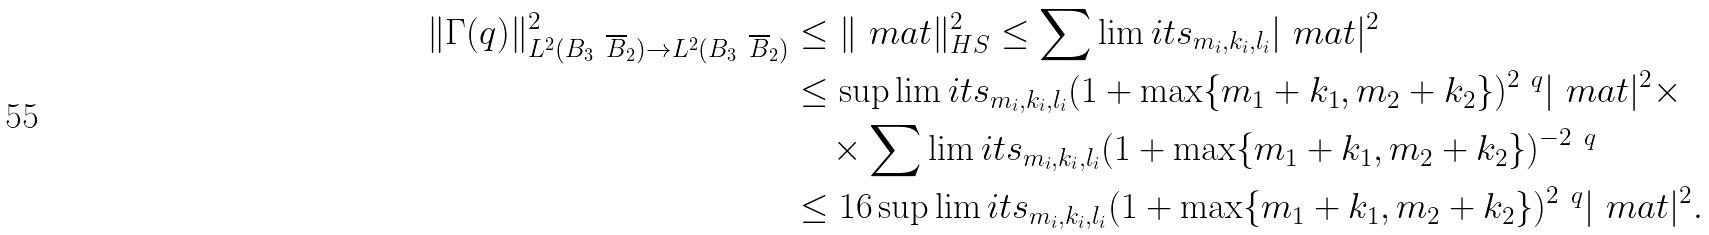Convert formula to latex. <formula><loc_0><loc_0><loc_500><loc_500>\| \Gamma ( q ) \| _ { L ^ { 2 } ( B _ { 3 } \ \overline { B } _ { 2 } ) \rightarrow L ^ { 2 } ( B _ { 3 } \ \overline { B } _ { 2 } ) } ^ { 2 } & \leq \| \ m a t \| _ { H S } ^ { 2 } \leq \sum \lim i t s _ { m _ { i } , k _ { i } , l _ { i } } | \ m a t | ^ { 2 } \\ & \leq \sup \lim i t s _ { m _ { i } , k _ { i } , l _ { i } } ( 1 + \max \{ m _ { 1 } + k _ { 1 } , m _ { 2 } + k _ { 2 } \} ) ^ { 2 \ q } | \ m a t | ^ { 2 } \times \\ & \quad \times \sum \lim i t s _ { m _ { i } , k _ { i } , l _ { i } } ( 1 + \max \{ m _ { 1 } + k _ { 1 } , m _ { 2 } + k _ { 2 } \} ) ^ { - 2 \ q } \\ & \leq 1 6 \sup \lim i t s _ { m _ { i } , k _ { i } , l _ { i } } ( 1 + \max \{ m _ { 1 } + k _ { 1 } , m _ { 2 } + k _ { 2 } \} ) ^ { 2 \ q } | \ m a t | ^ { 2 } .</formula> 